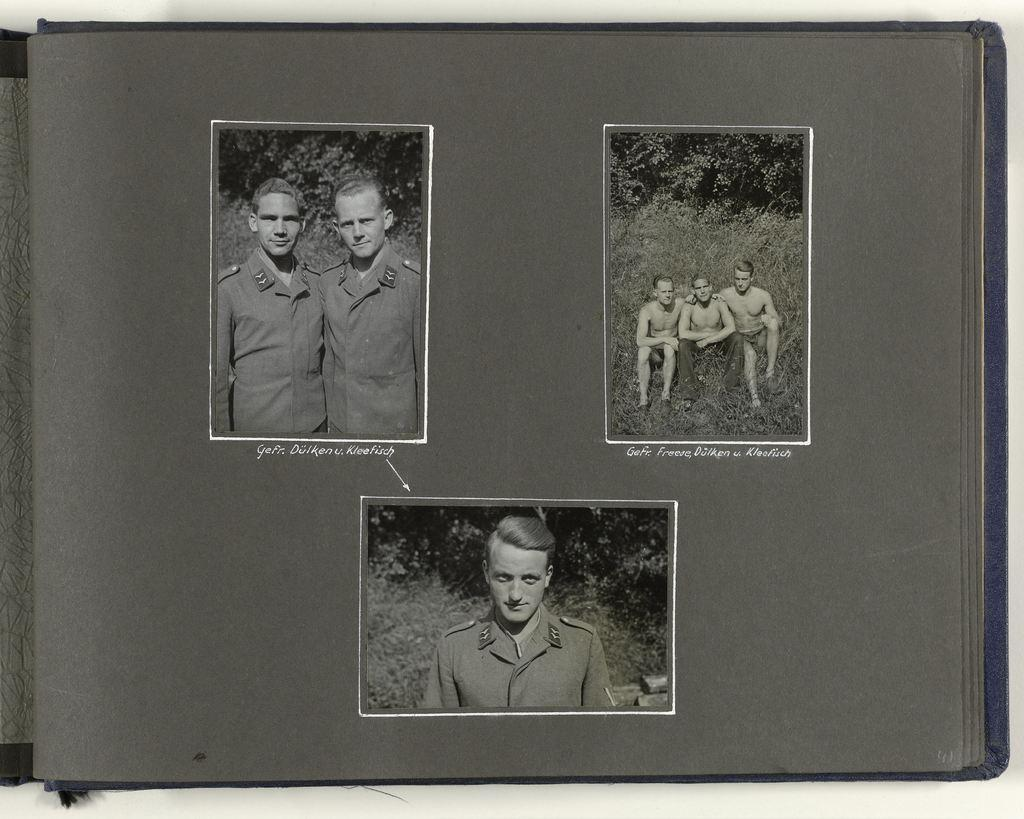What is the main subject of the image? The main subject of the image is the cover page of a book. What can be seen on the cover page? There are pictures of persons on the cover page. What type of liquid is being used to write on the cover page? There is no liquid present on the cover page, as it is a book cover with pictures of persons. 